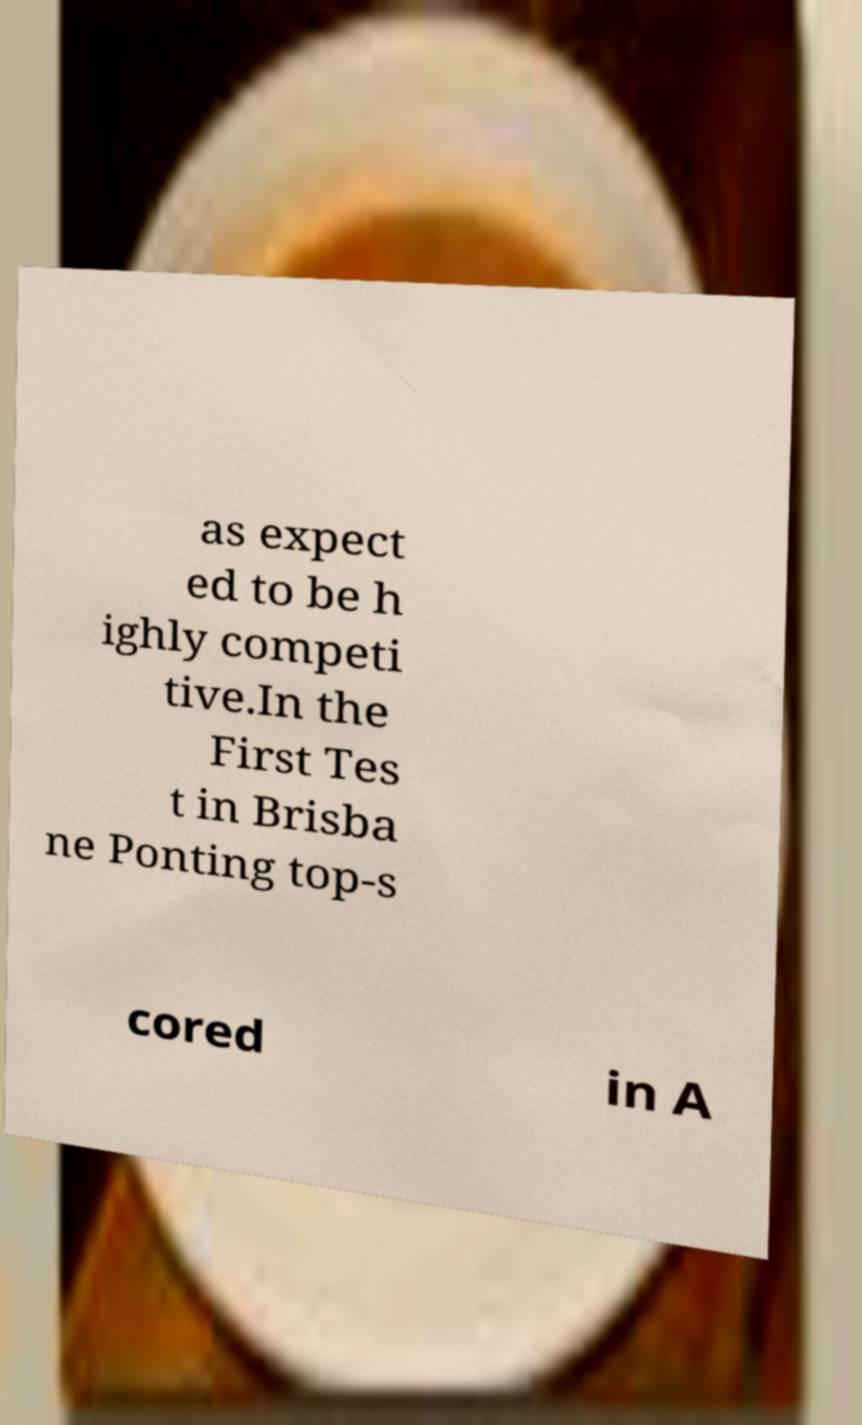I need the written content from this picture converted into text. Can you do that? as expect ed to be h ighly competi tive.In the First Tes t in Brisba ne Ponting top-s cored in A 